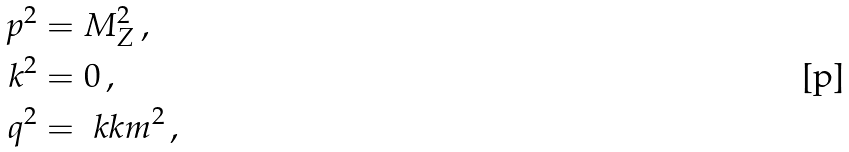<formula> <loc_0><loc_0><loc_500><loc_500>p ^ { 2 } & = M _ { Z } ^ { 2 } \, , \\ k ^ { 2 } & = 0 \, , \\ q ^ { 2 } & = \ k k m ^ { 2 } \, ,</formula> 